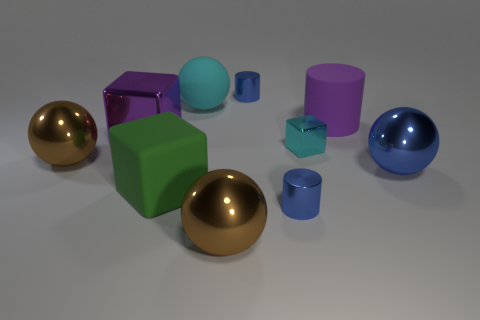Subtract all cylinders. How many objects are left? 7 Add 8 purple metal blocks. How many purple metal blocks are left? 9 Add 8 small red metal blocks. How many small red metal blocks exist? 8 Subtract 0 gray cylinders. How many objects are left? 10 Subtract all small gray metal balls. Subtract all green matte objects. How many objects are left? 9 